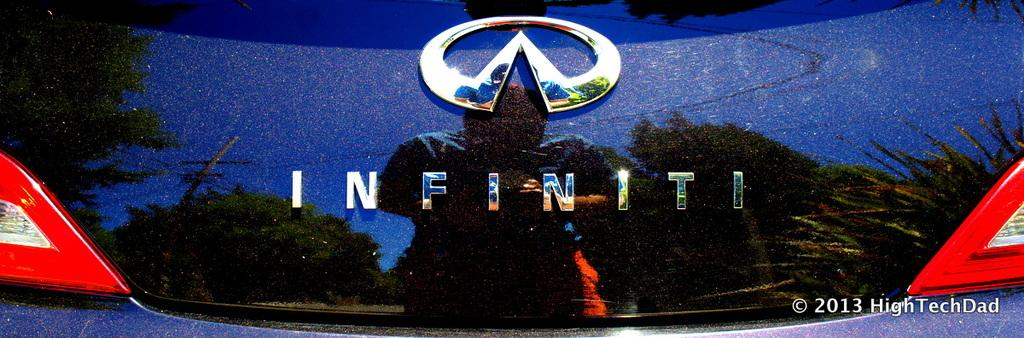What is the main subject of the image? The main subject of the image is the logo of a car. What type of sound can be heard coming from the goldfish in the image? There is no goldfish present in the image, and therefore no sound can be heard from it. 